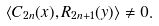<formula> <loc_0><loc_0><loc_500><loc_500>\langle C _ { 2 n } ( x ) , R _ { 2 n + 1 } ( y ) \rangle \ne 0 .</formula> 